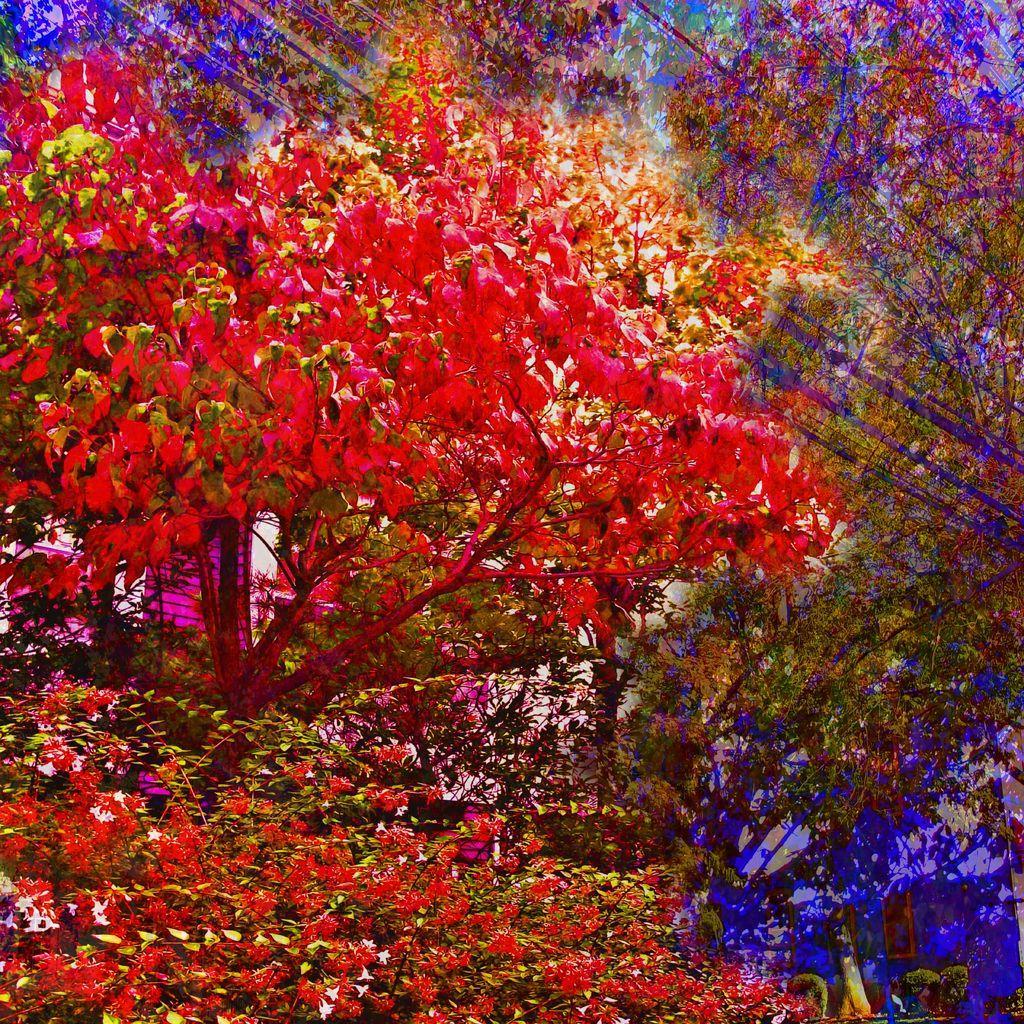Could you give a brief overview of what you see in this image? This is an edited image. In this image we can see flowers to the trees that are in red color and sky. 